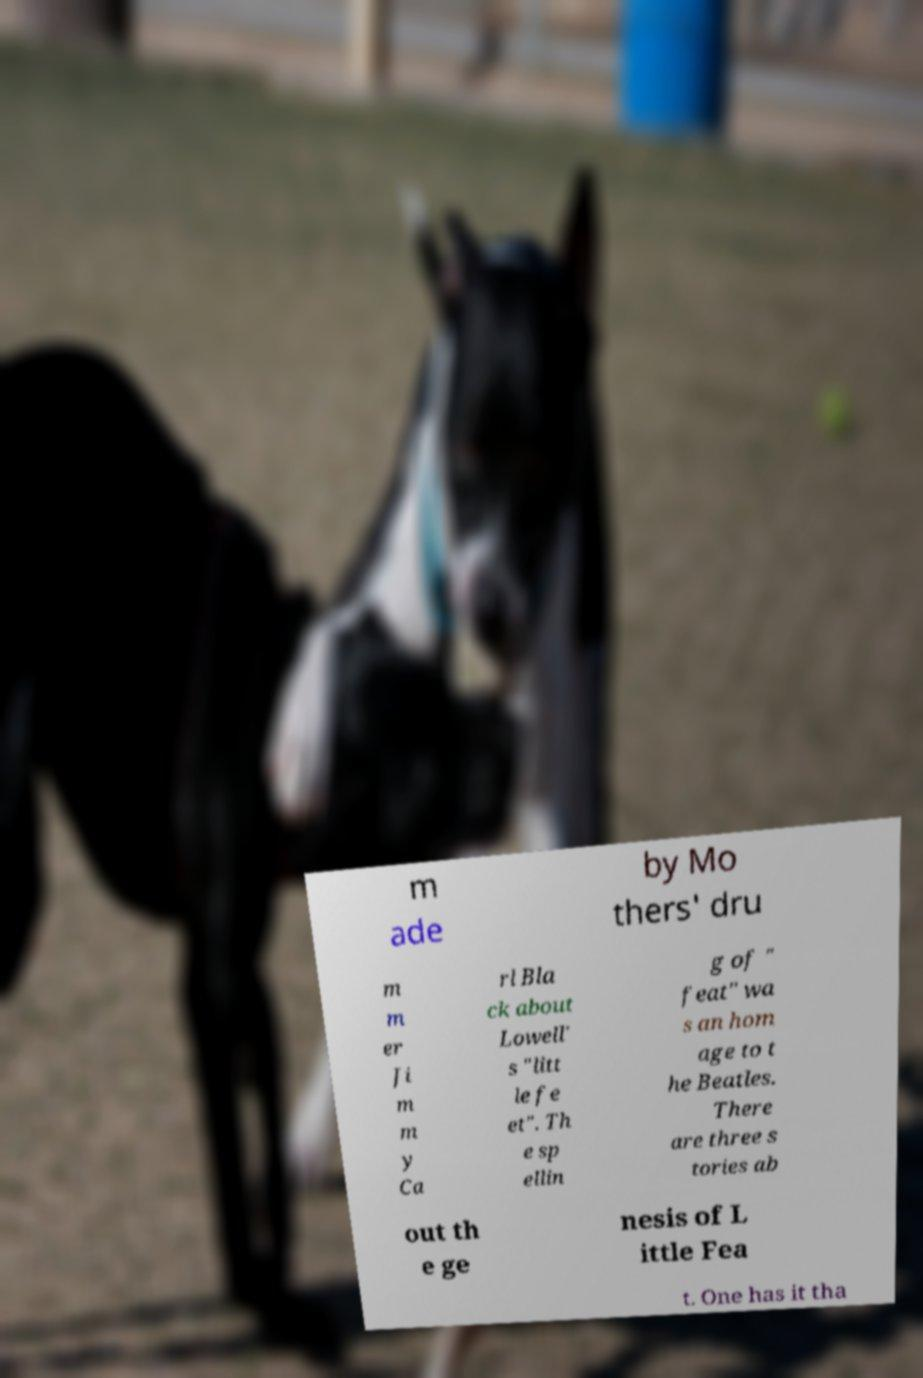Please read and relay the text visible in this image. What does it say? m ade by Mo thers' dru m m er Ji m m y Ca rl Bla ck about Lowell' s "litt le fe et". Th e sp ellin g of " feat" wa s an hom age to t he Beatles. There are three s tories ab out th e ge nesis of L ittle Fea t. One has it tha 